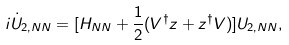<formula> <loc_0><loc_0><loc_500><loc_500>i \dot { U } _ { 2 , N N } = [ H _ { N N } + \frac { 1 } { 2 } ( { V } ^ { \dagger } { z } + { z } ^ { \dagger } { V } ) ] U _ { 2 , N N } ,</formula> 